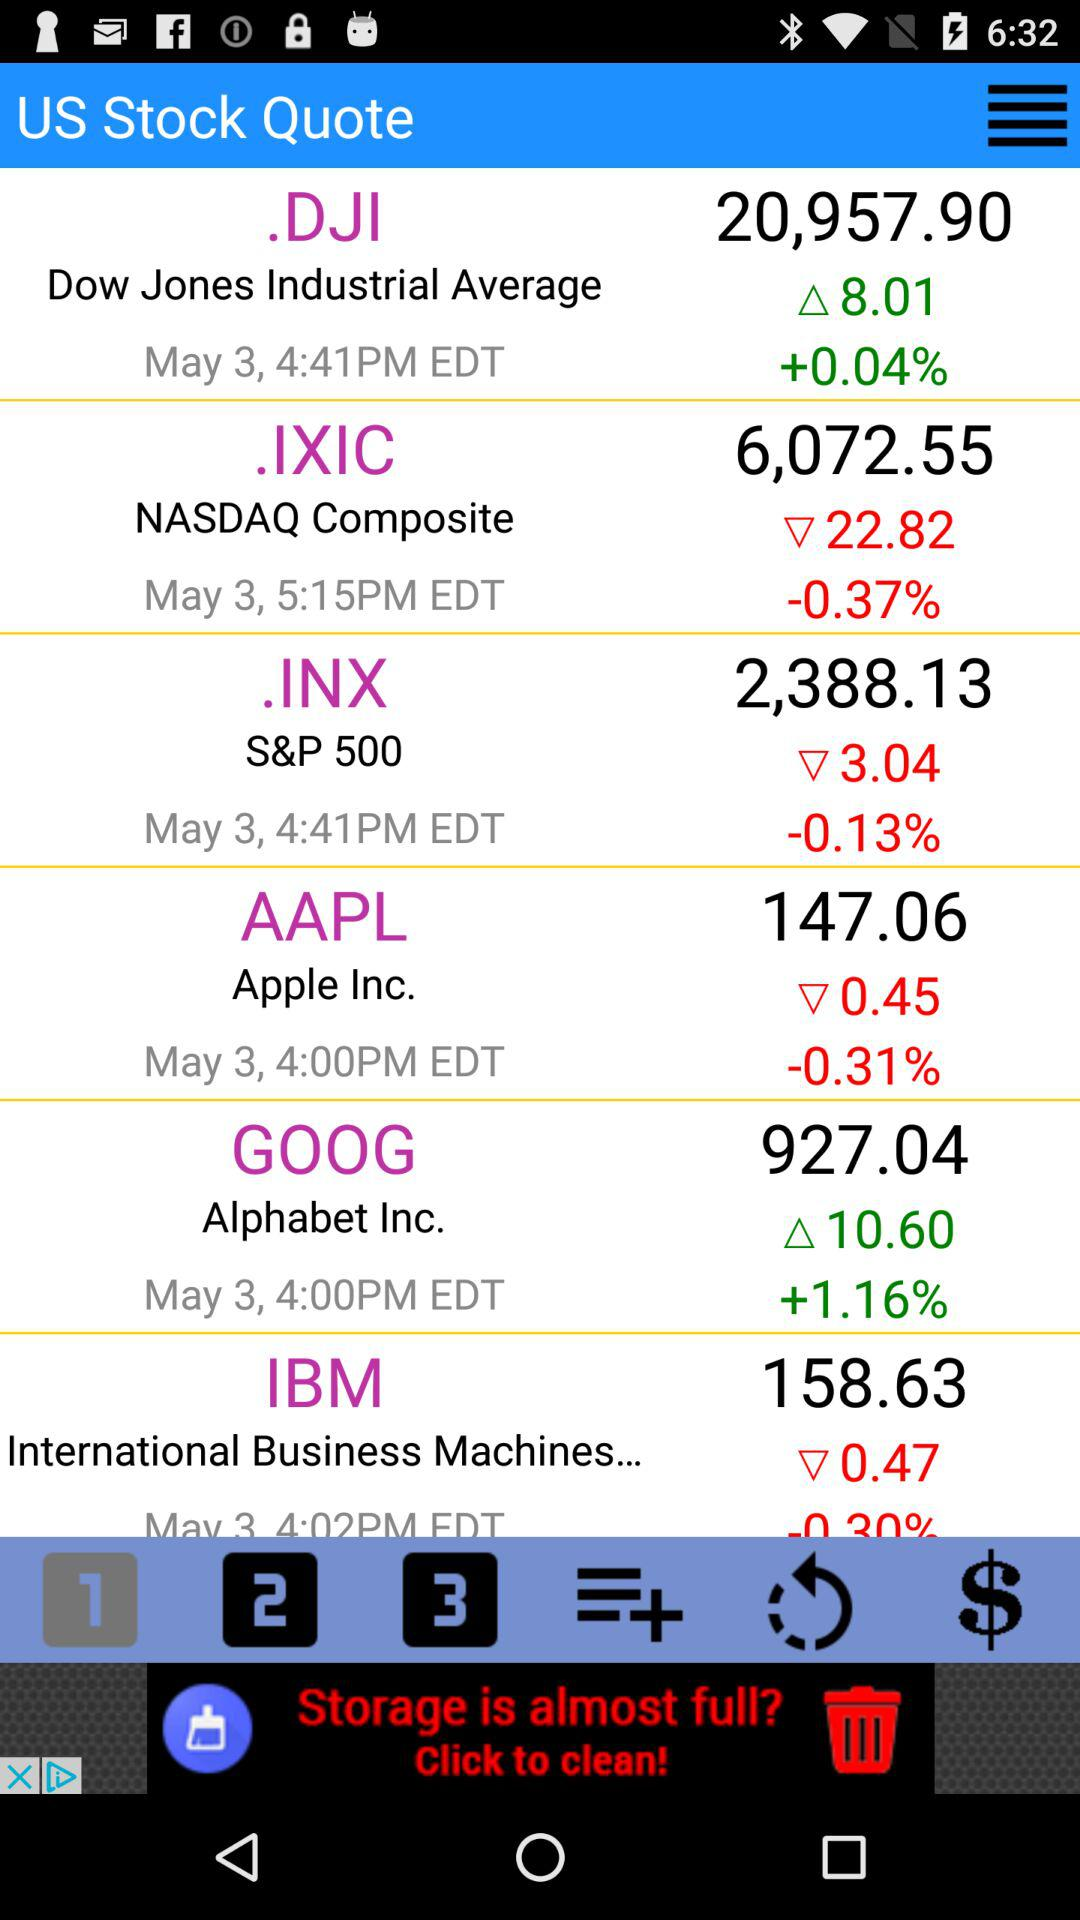What is the stock price of the Dow Jones Industrial Average? The stock price is 20,957.90. 